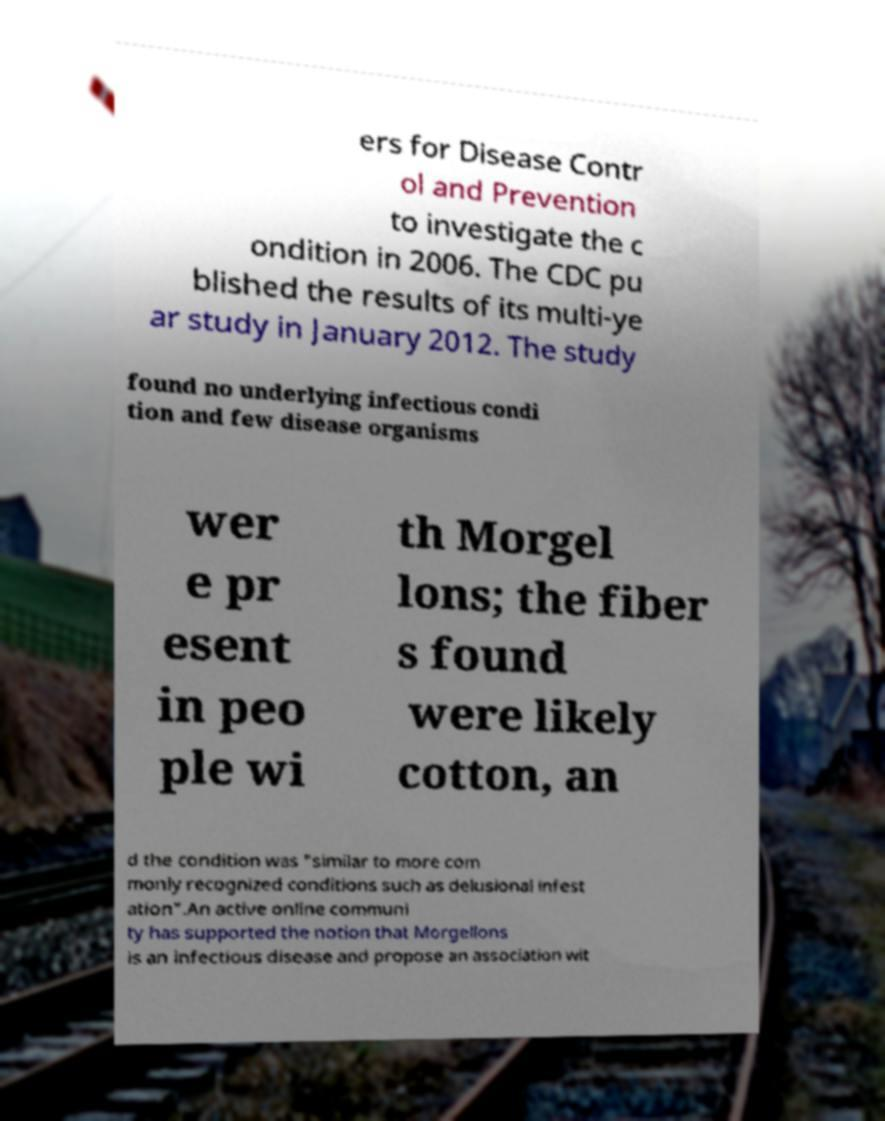Could you extract and type out the text from this image? ers for Disease Contr ol and Prevention to investigate the c ondition in 2006. The CDC pu blished the results of its multi-ye ar study in January 2012. The study found no underlying infectious condi tion and few disease organisms wer e pr esent in peo ple wi th Morgel lons; the fiber s found were likely cotton, an d the condition was "similar to more com monly recognized conditions such as delusional infest ation".An active online communi ty has supported the notion that Morgellons is an infectious disease and propose an association wit 